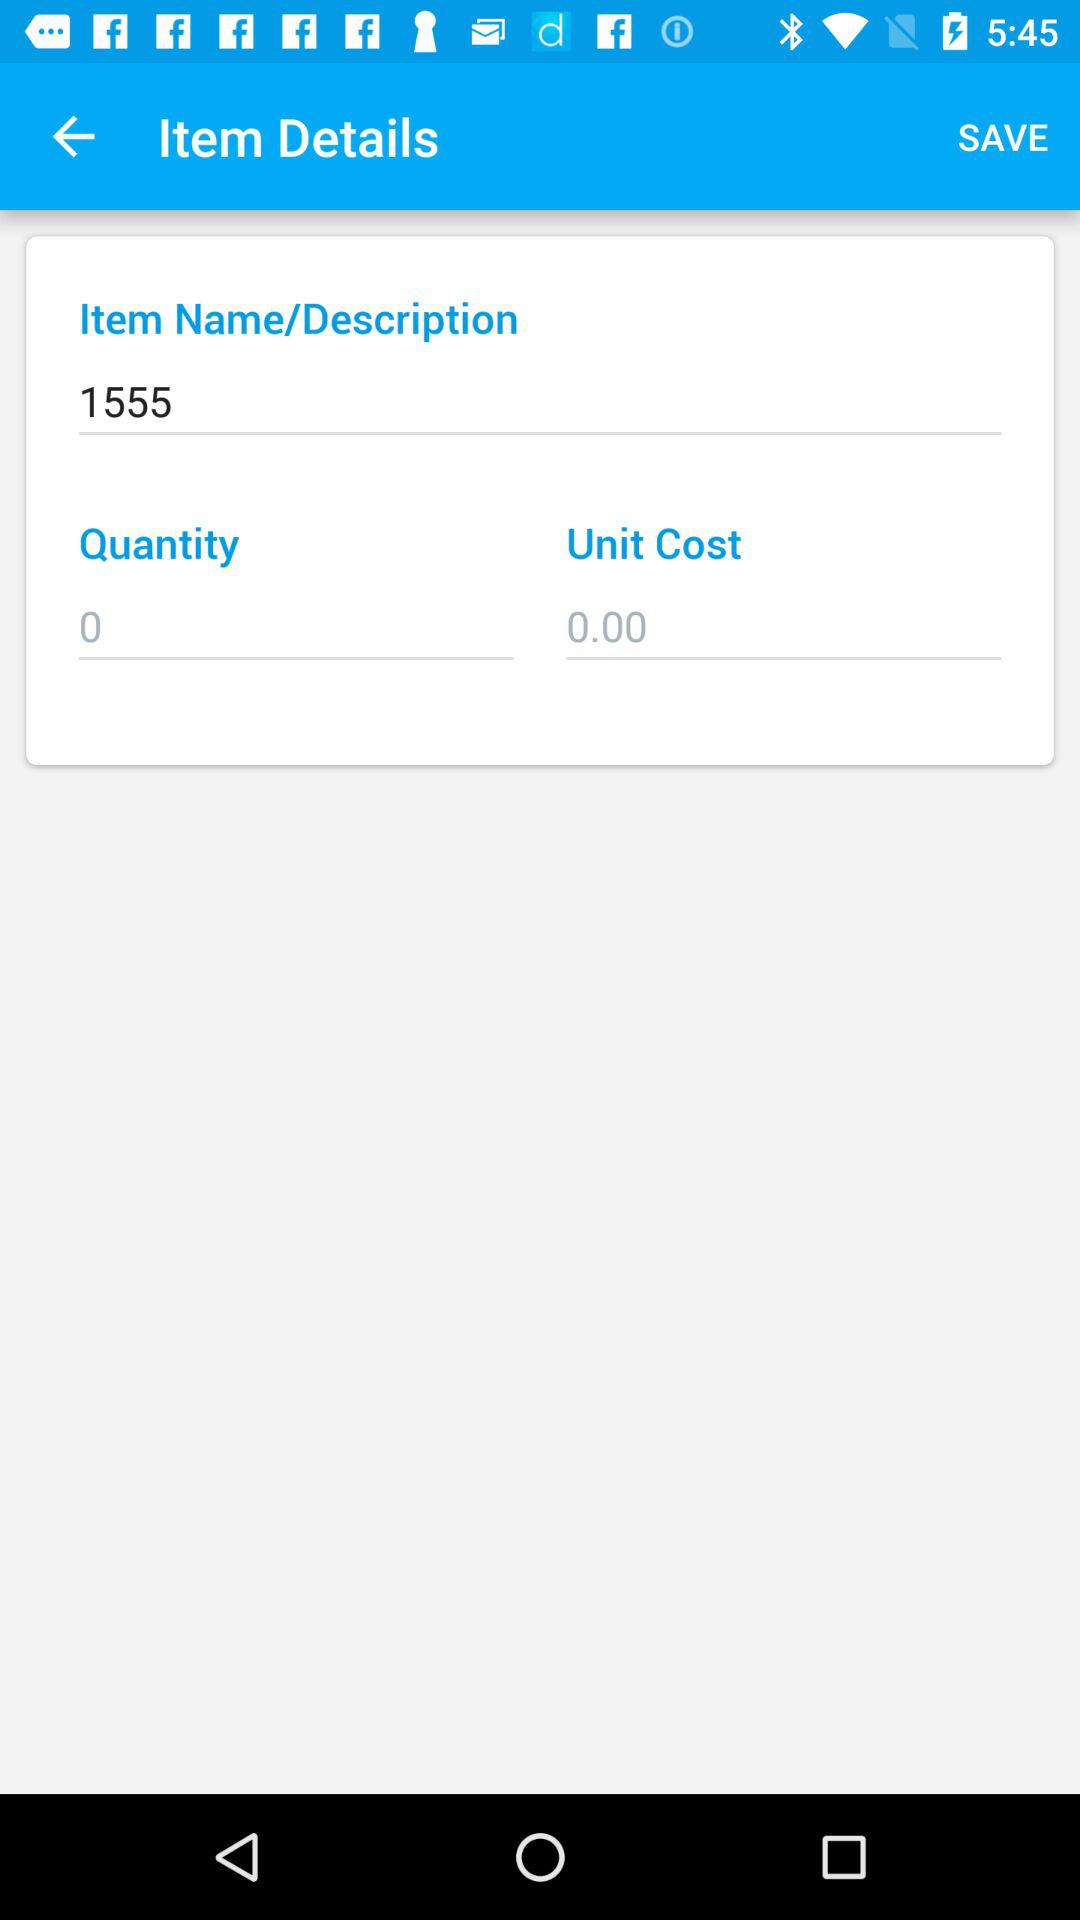What is the name of the item? The name of the item is 1555. 